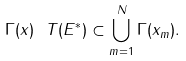<formula> <loc_0><loc_0><loc_500><loc_500>\Gamma ( x ) \ T ( E ^ { * } ) \subset \bigcup _ { m = 1 } ^ { N } \Gamma ( x _ { m } ) .</formula> 